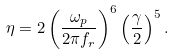Convert formula to latex. <formula><loc_0><loc_0><loc_500><loc_500>\eta = 2 \left ( \frac { \omega _ { p } } { 2 \pi f _ { r } } \right ) ^ { 6 } \left ( \frac { \gamma } { 2 } \right ) ^ { 5 } .</formula> 